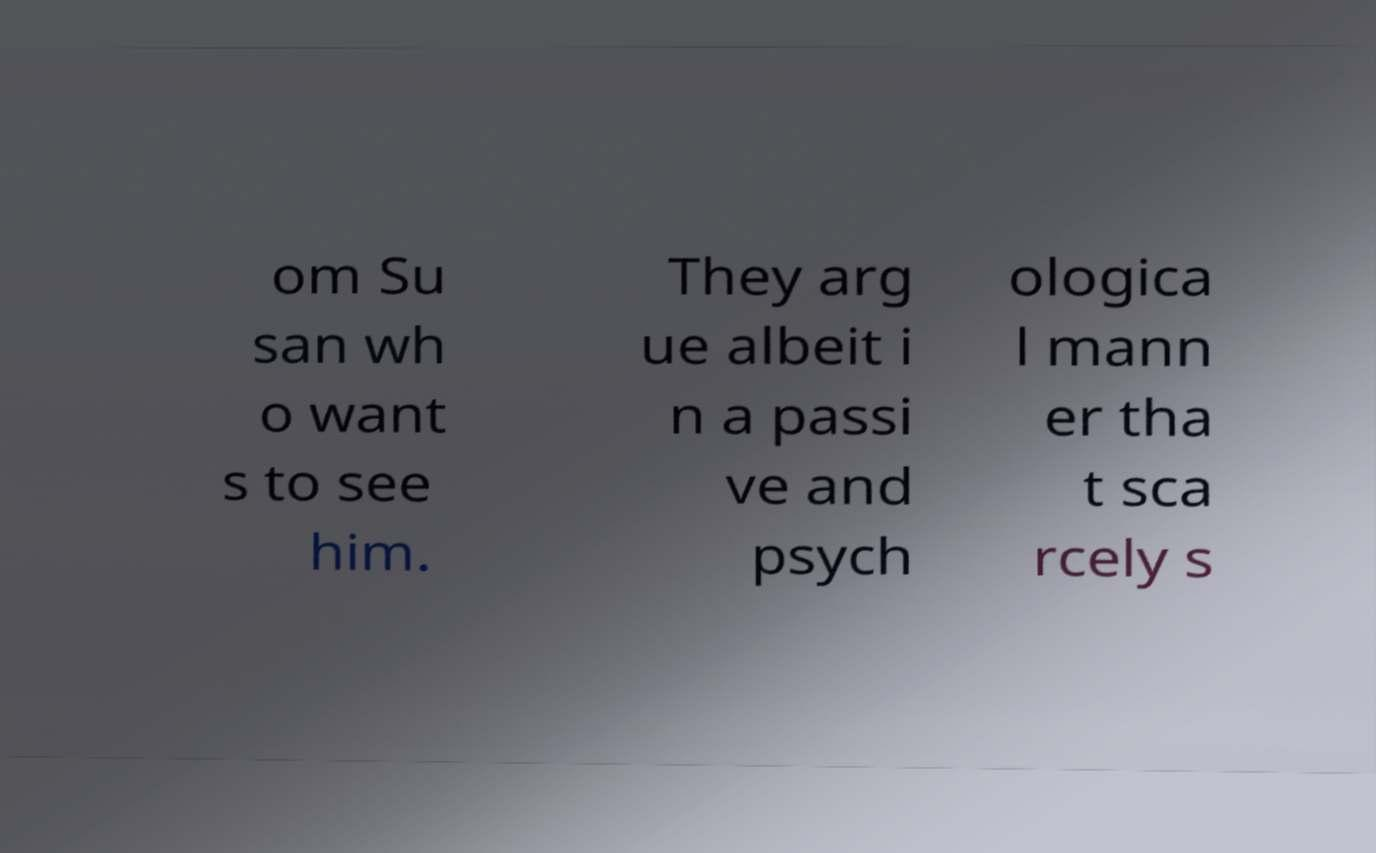What messages or text are displayed in this image? I need them in a readable, typed format. om Su san wh o want s to see him. They arg ue albeit i n a passi ve and psych ologica l mann er tha t sca rcely s 